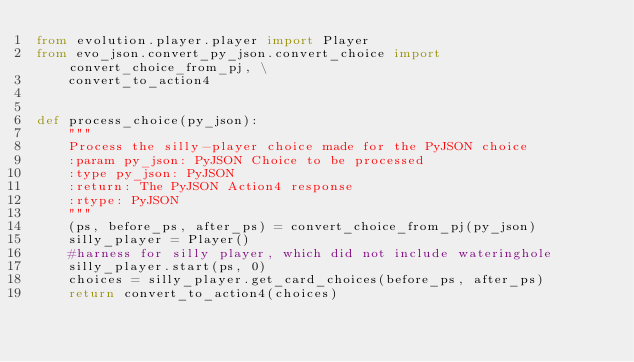Convert code to text. <code><loc_0><loc_0><loc_500><loc_500><_Python_>from evolution.player.player import Player
from evo_json.convert_py_json.convert_choice import convert_choice_from_pj, \
    convert_to_action4


def process_choice(py_json):
    """
    Process the silly-player choice made for the PyJSON choice
    :param py_json: PyJSON Choice to be processed
    :type py_json: PyJSON
    :return: The PyJSON Action4 response
    :rtype: PyJSON
    """
    (ps, before_ps, after_ps) = convert_choice_from_pj(py_json)
    silly_player = Player()
    #harness for silly player, which did not include wateringhole
    silly_player.start(ps, 0)
    choices = silly_player.get_card_choices(before_ps, after_ps)
    return convert_to_action4(choices)
</code> 